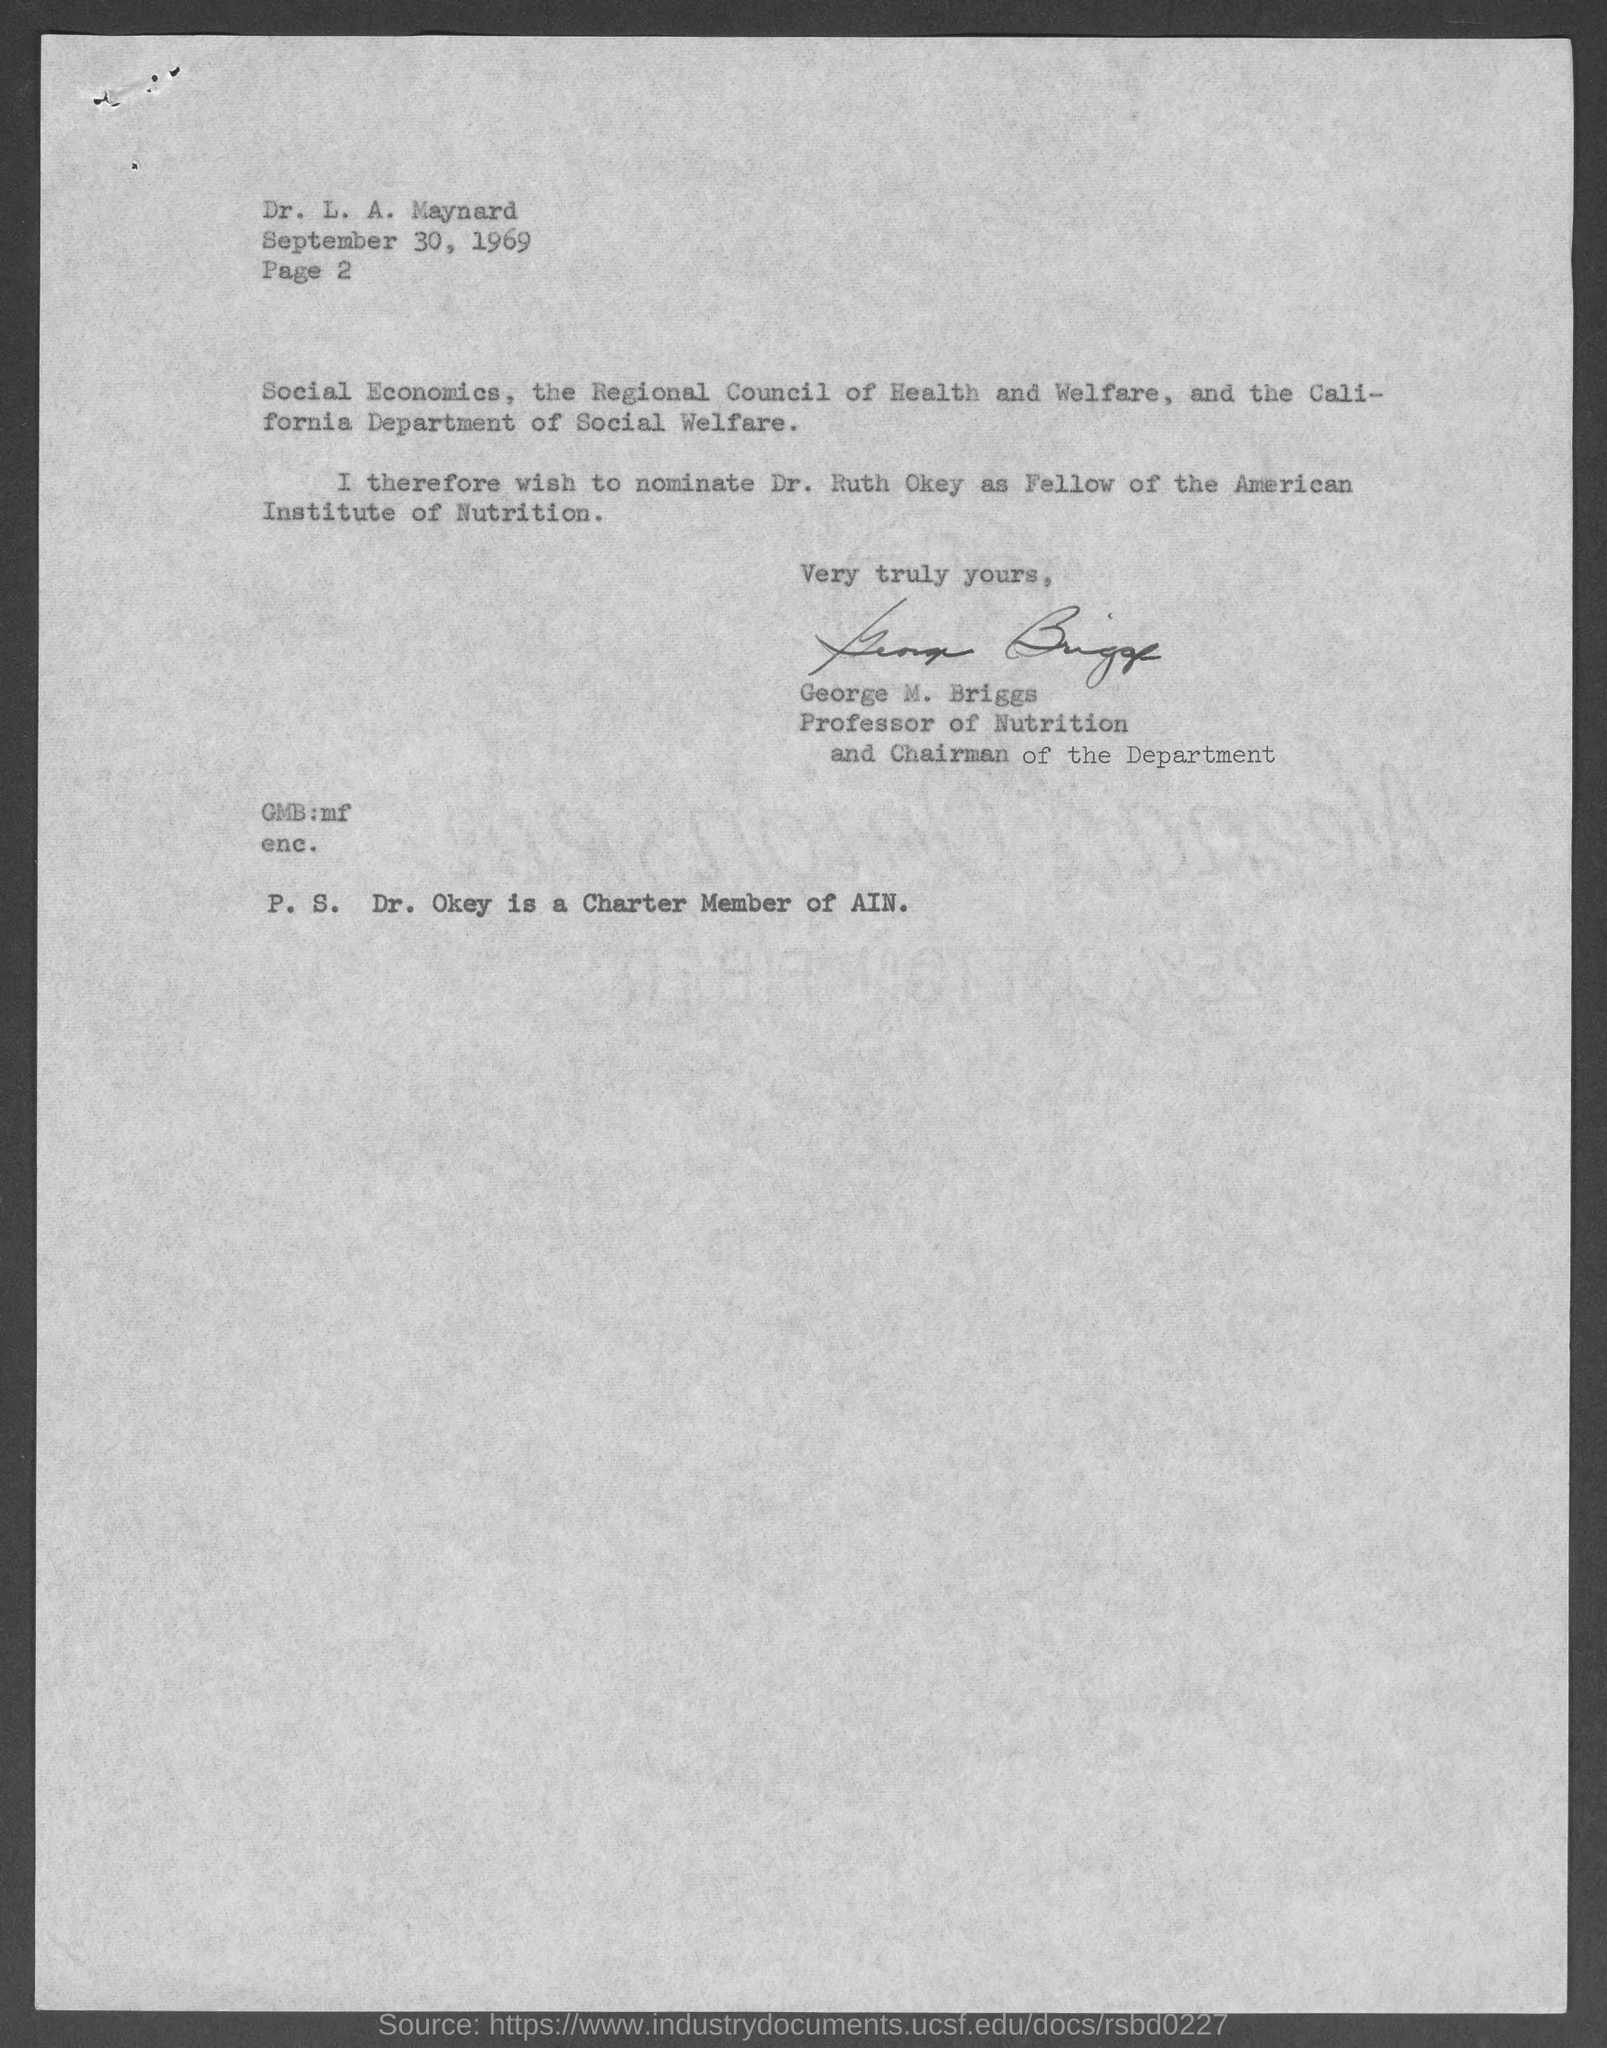Who wrote this letter?
Offer a terse response. George M. Briggs. What is the position of george m. briggs ?
Your response must be concise. Professor of Nutrition and Chairman of the Department. Who is the charter member of ain?
Your answer should be compact. Dr. Okey. What does ain stand for ?
Provide a short and direct response. American Institute of Nutrition. To whom is this letter written to?
Your response must be concise. Dr. L. A. Maynard. The letter is dated on?
Make the answer very short. September 30, 1969. What is the page number ?
Your answer should be very brief. 2. 